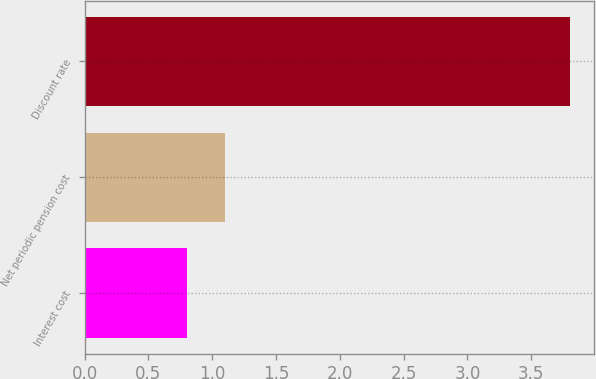Convert chart to OTSL. <chart><loc_0><loc_0><loc_500><loc_500><bar_chart><fcel>Interest cost<fcel>Net periodic pension cost<fcel>Discount rate<nl><fcel>0.8<fcel>1.1<fcel>3.8<nl></chart> 